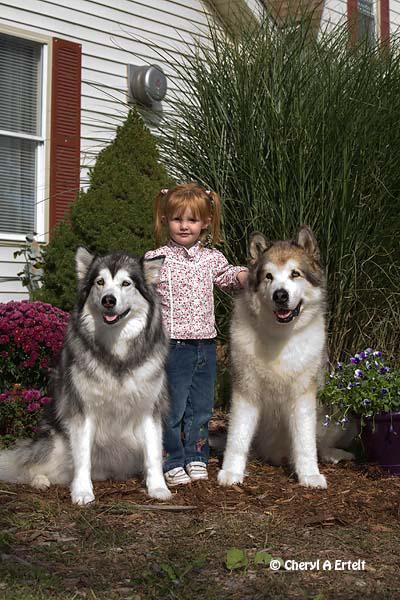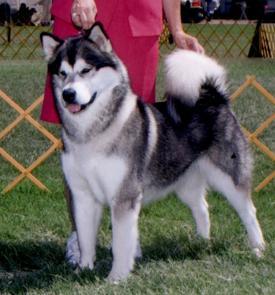The first image is the image on the left, the second image is the image on the right. Given the left and right images, does the statement "The left image features one dog, which is facing rightward, and the right image features a reclining dog with its head upright and body facing forward." hold true? Answer yes or no. No. The first image is the image on the left, the second image is the image on the right. Examine the images to the left and right. Is the description "There is at least one human in the image pair." accurate? Answer yes or no. Yes. 